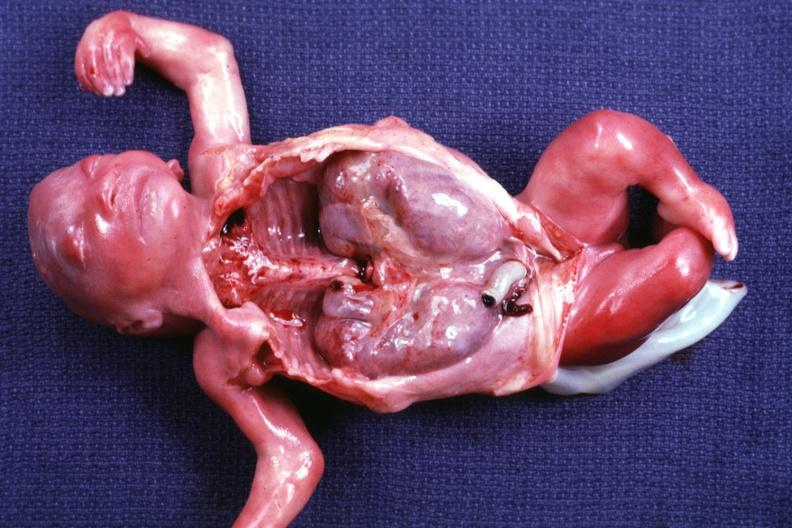s retroperitoneal leiomyosarcoma of kidneys present?
Answer the question using a single word or phrase. No 